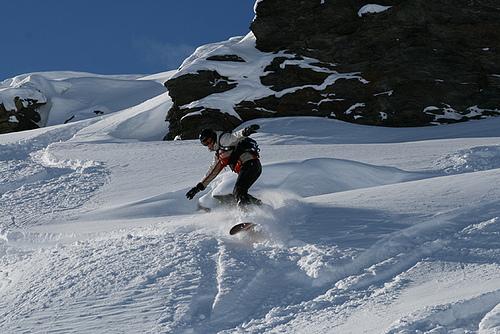What sport is this?
Answer briefly. Snowboarding. Are they doing this sport on the snow?
Write a very short answer. Yes. Is it snowing?
Short answer required. No. 